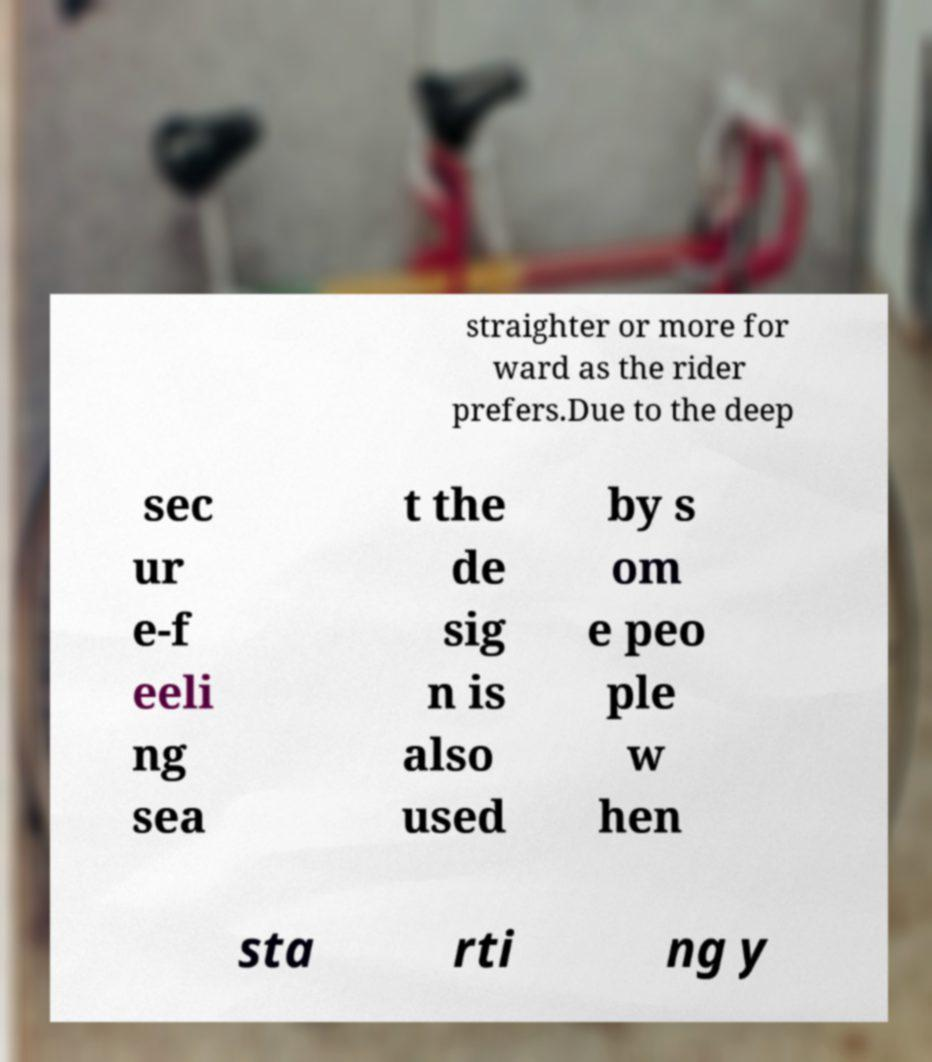For documentation purposes, I need the text within this image transcribed. Could you provide that? straighter or more for ward as the rider prefers.Due to the deep sec ur e-f eeli ng sea t the de sig n is also used by s om e peo ple w hen sta rti ng y 